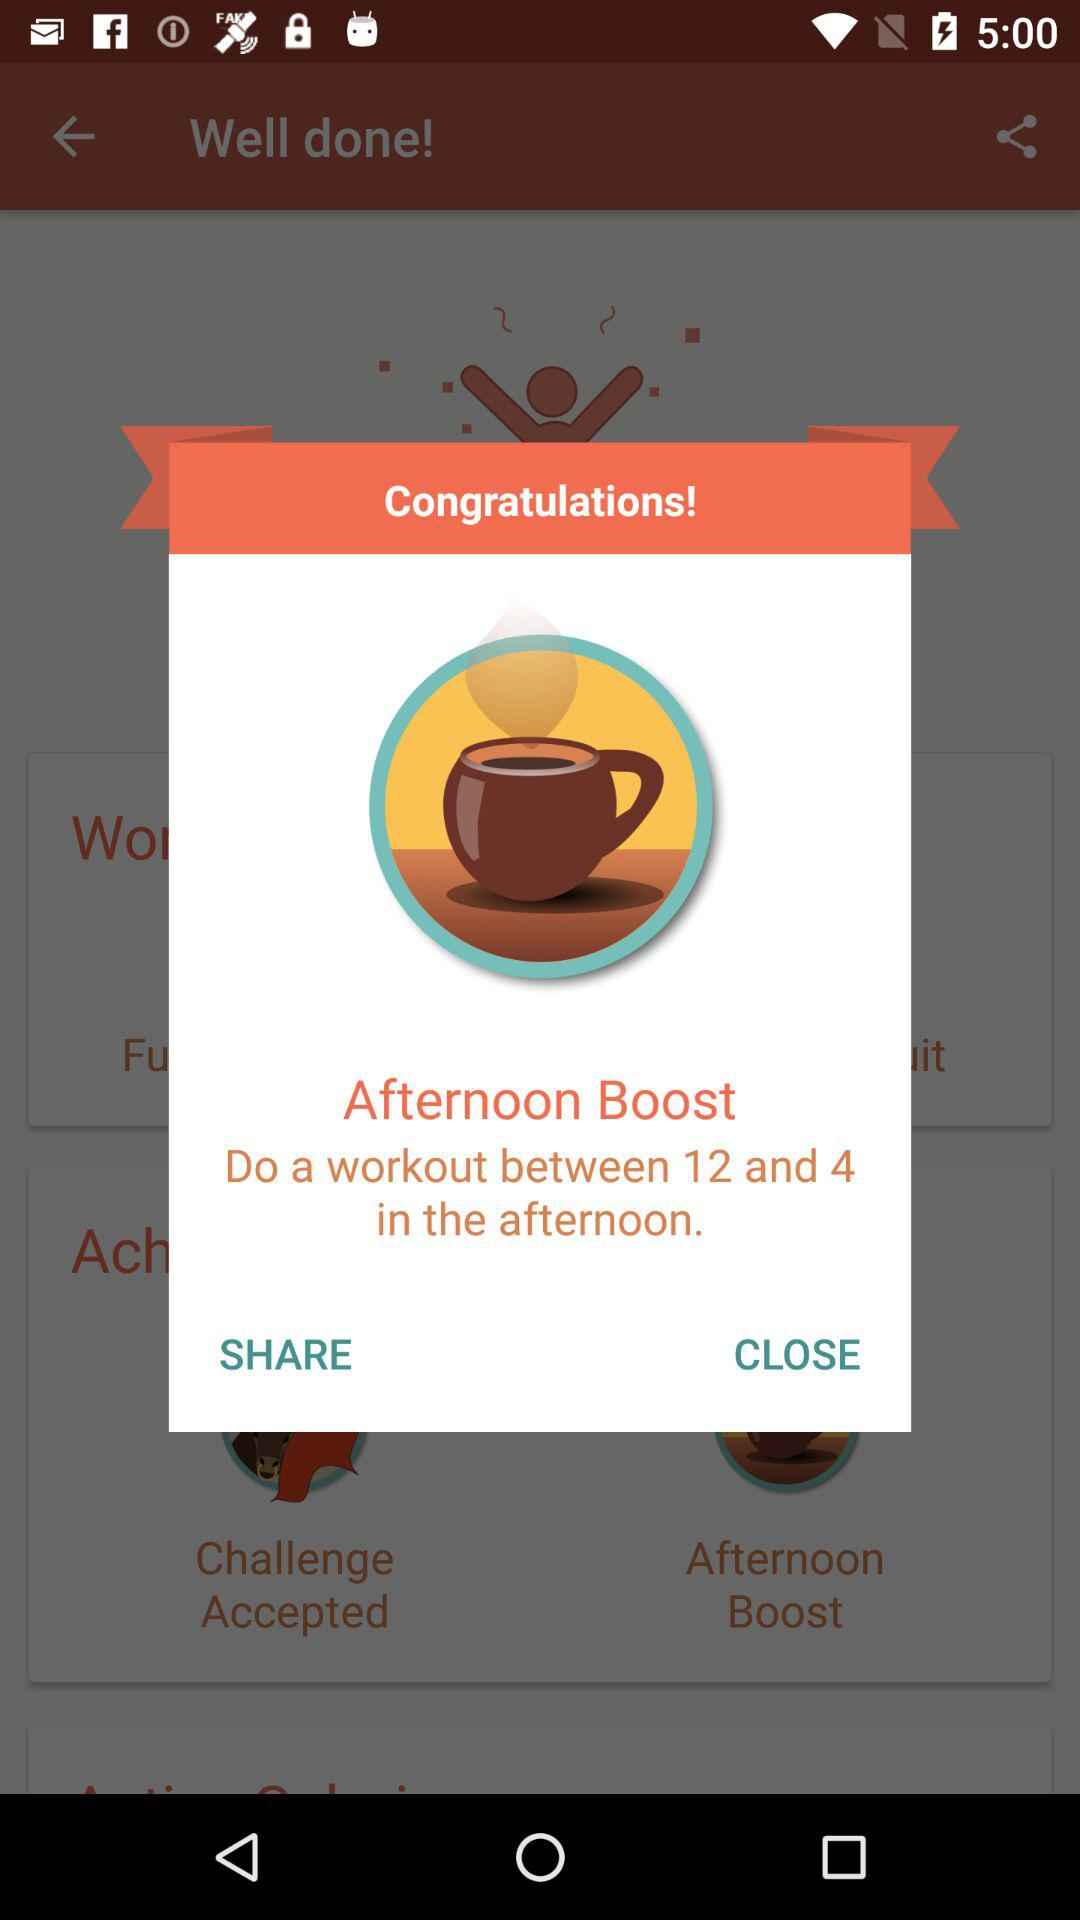Through which application can content be shared?
When the provided information is insufficient, respond with <no answer>. <no answer> 